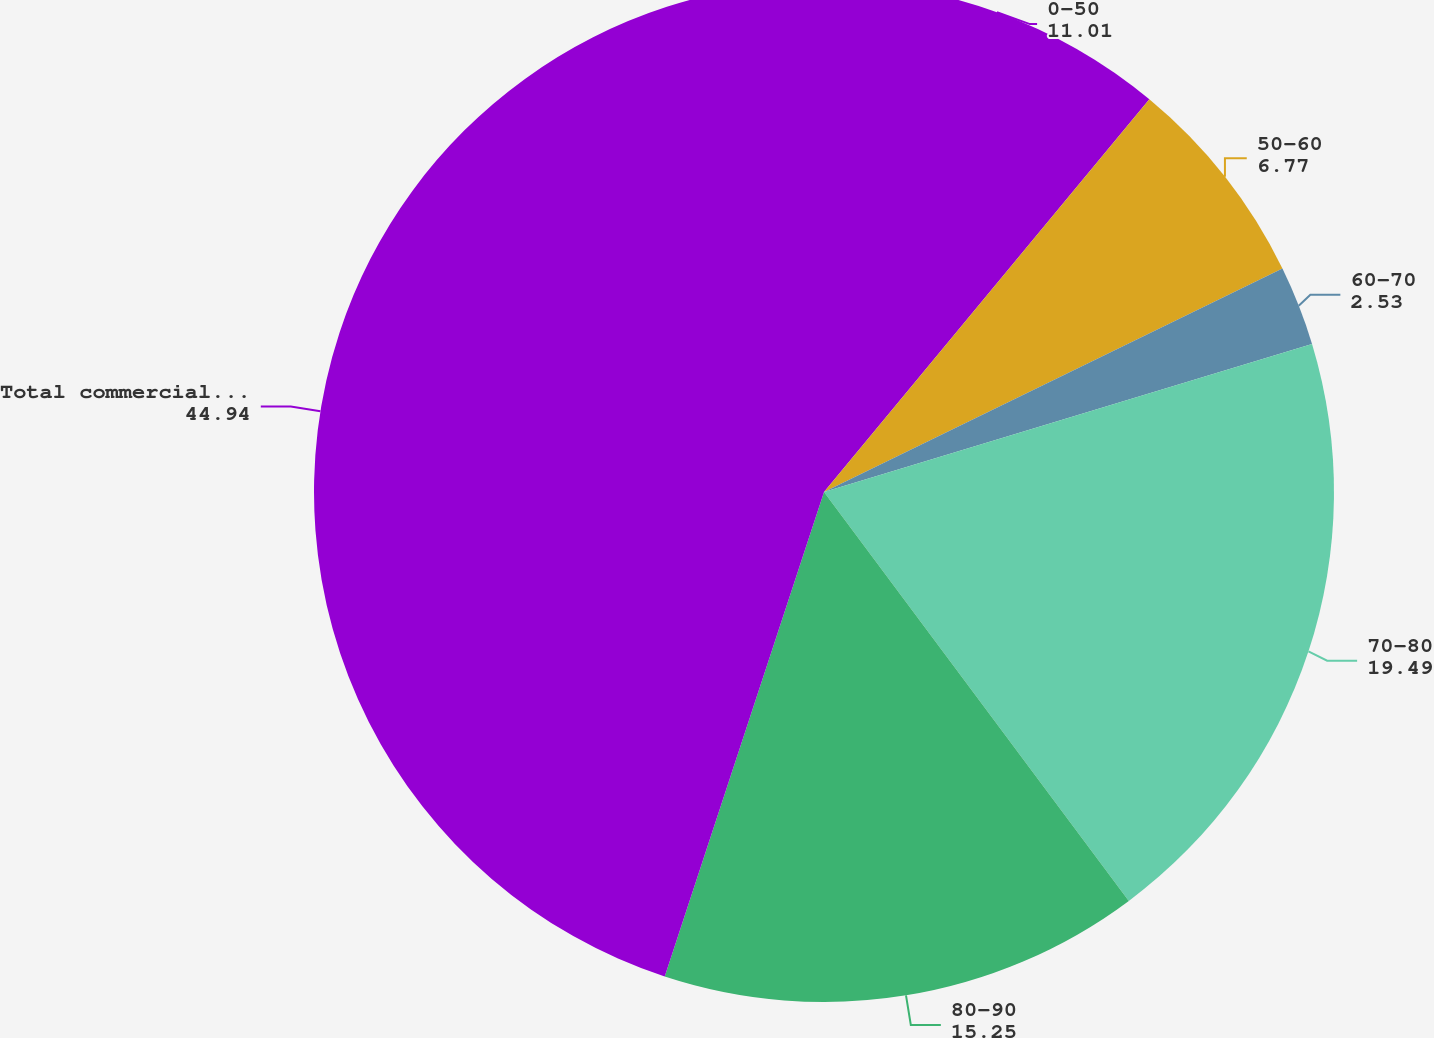Convert chart to OTSL. <chart><loc_0><loc_0><loc_500><loc_500><pie_chart><fcel>0-50<fcel>50-60<fcel>60-70<fcel>70-80<fcel>80-90<fcel>Total commercial mortgage<nl><fcel>11.01%<fcel>6.77%<fcel>2.53%<fcel>19.49%<fcel>15.25%<fcel>44.94%<nl></chart> 